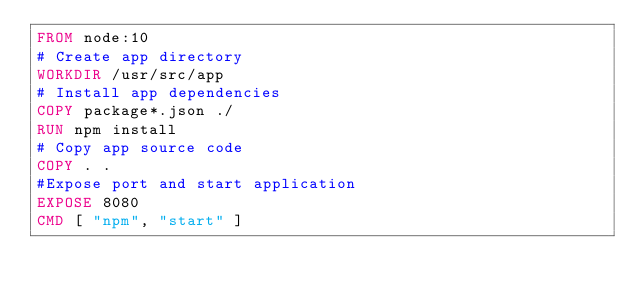Convert code to text. <code><loc_0><loc_0><loc_500><loc_500><_Dockerfile_>FROM node:10
# Create app directory
WORKDIR /usr/src/app
# Install app dependencies
COPY package*.json ./
RUN npm install
# Copy app source code
COPY . .
#Expose port and start application
EXPOSE 8080
CMD [ "npm", "start" ]

</code> 